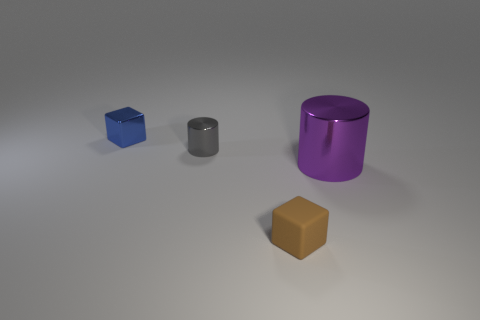Subtract all brown cubes. How many cubes are left? 1 Subtract 1 blocks. How many blocks are left? 1 Add 1 big shiny objects. How many objects exist? 5 Add 3 small brown blocks. How many small brown blocks are left? 4 Add 2 small gray matte things. How many small gray matte things exist? 2 Subtract 0 green cylinders. How many objects are left? 4 Subtract all purple cubes. Subtract all green balls. How many cubes are left? 2 Subtract all purple metallic things. Subtract all purple shiny cylinders. How many objects are left? 2 